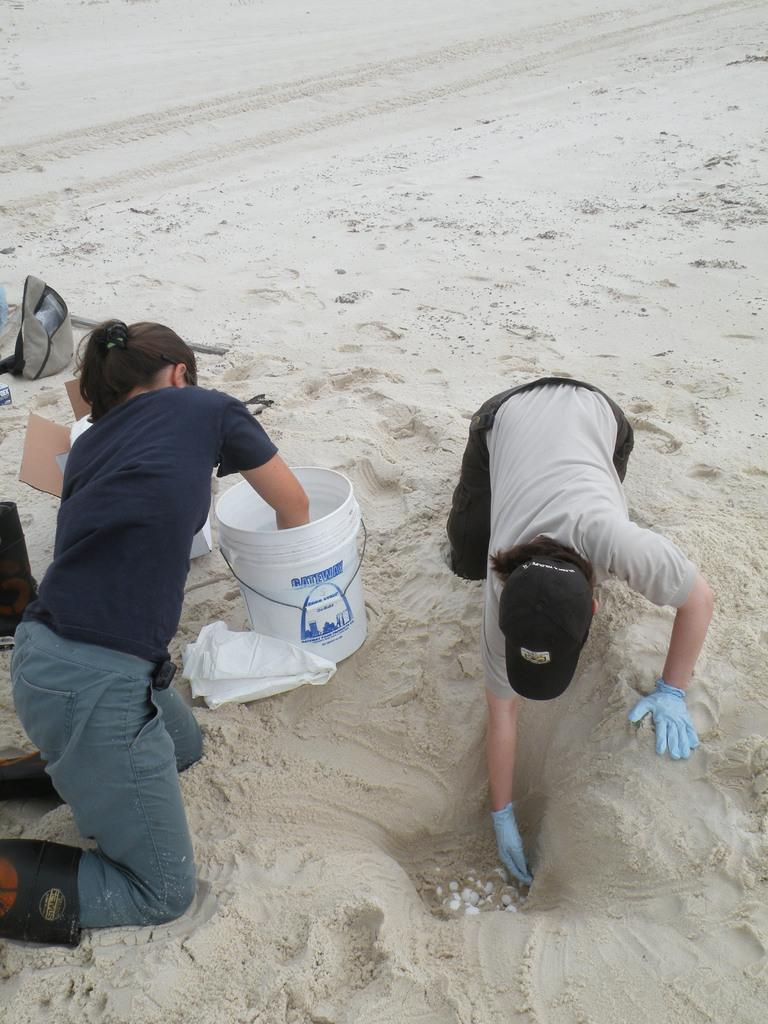How many people are present in the image? There are two members in the image. Where are the members located? The members are on the land. What object can be seen in the middle of the image? There is a bucket in the middle of the image. What is the color of the bucket? The bucket is white in color. What role does the actor play in the battle depicted in the image? There is no actor or battle present in the image; it features two members on the land with a white bucket. How does the acoustics of the image affect the sound quality of the scene? The image does not depict a scene with sound, so there is no acoustics to consider. 